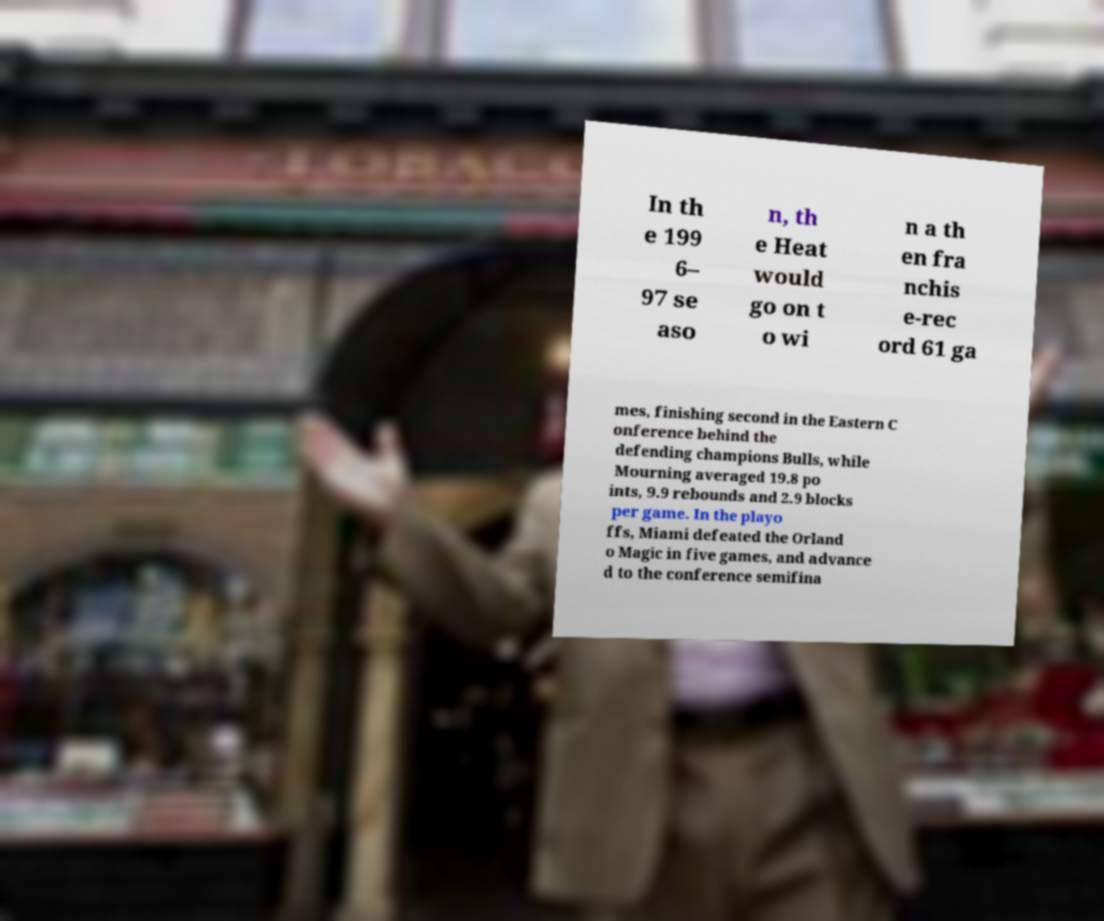Can you accurately transcribe the text from the provided image for me? In th e 199 6– 97 se aso n, th e Heat would go on t o wi n a th en fra nchis e-rec ord 61 ga mes, finishing second in the Eastern C onference behind the defending champions Bulls, while Mourning averaged 19.8 po ints, 9.9 rebounds and 2.9 blocks per game. In the playo ffs, Miami defeated the Orland o Magic in five games, and advance d to the conference semifina 